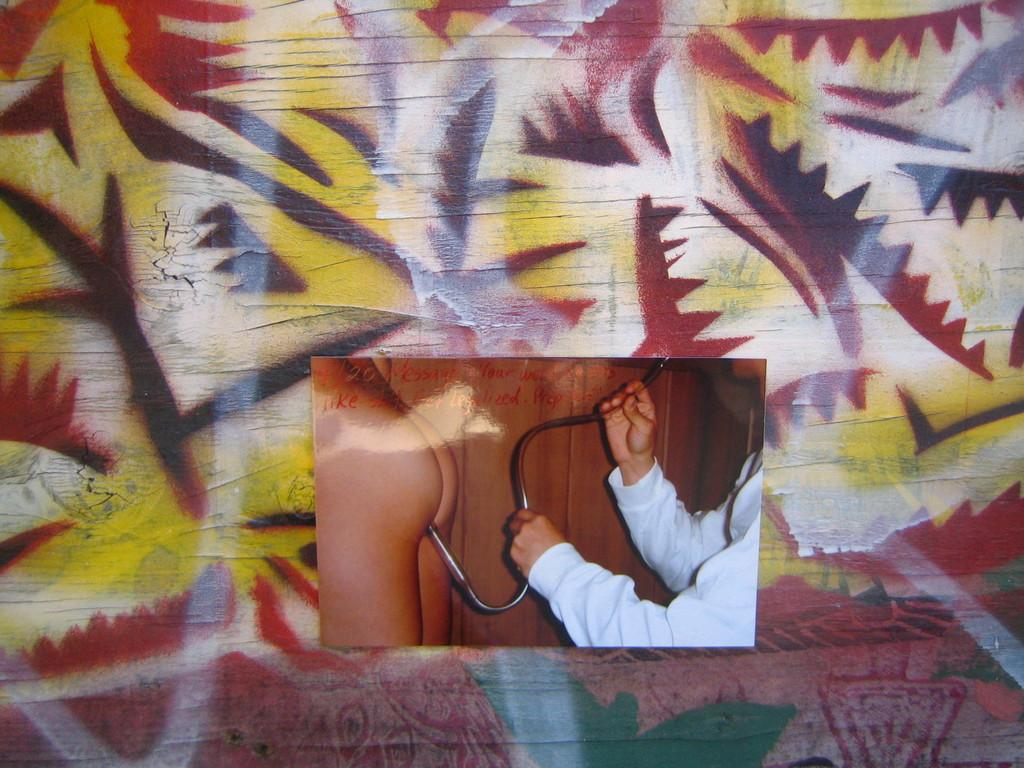What is located in the center of the image? There are persons and an object in the center of the image. Can you describe the persons in the image? Unfortunately, the provided facts do not give any information about the persons' appearance or actions. What is the object in the center of the image? The facts do not specify the type of object in the image. What can be seen in the background of the image? There is a wall in the background of the image. What type of quilt is being used by the persons in the image? There is no mention of a quilt in the provided facts, and therefore it cannot be determined if a quilt is present or being used. How many sisters are visible in the image? The provided facts do not mention any sisters or the number of persons in the image. 